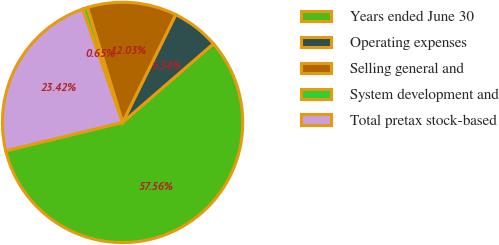Convert chart to OTSL. <chart><loc_0><loc_0><loc_500><loc_500><pie_chart><fcel>Years ended June 30<fcel>Operating expenses<fcel>Selling general and<fcel>System development and<fcel>Total pretax stock-based<nl><fcel>57.57%<fcel>6.34%<fcel>12.03%<fcel>0.65%<fcel>23.42%<nl></chart> 